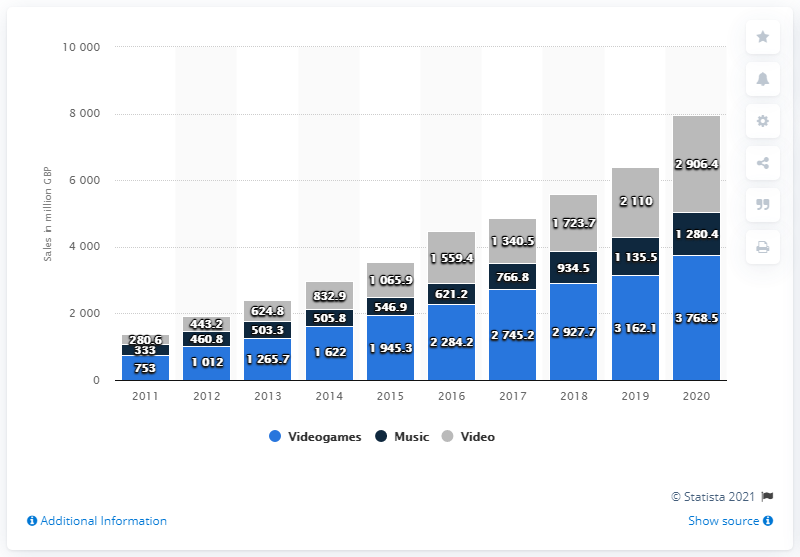Identify some key points in this picture. In 2020, digital video game sales in the UK reached a significant amount of 3768.5. 